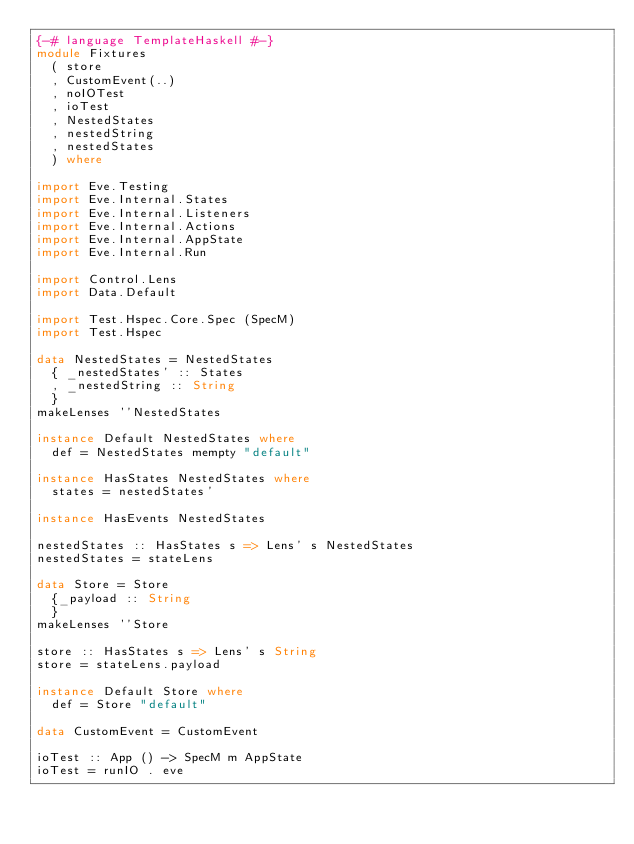<code> <loc_0><loc_0><loc_500><loc_500><_Haskell_>{-# language TemplateHaskell #-}
module Fixtures
  ( store
  , CustomEvent(..)
  , noIOTest
  , ioTest
  , NestedStates
  , nestedString
  , nestedStates
  ) where

import Eve.Testing
import Eve.Internal.States
import Eve.Internal.Listeners
import Eve.Internal.Actions
import Eve.Internal.AppState
import Eve.Internal.Run

import Control.Lens
import Data.Default

import Test.Hspec.Core.Spec (SpecM)
import Test.Hspec

data NestedStates = NestedStates
  { _nestedStates' :: States
  , _nestedString :: String
  }
makeLenses ''NestedStates

instance Default NestedStates where
  def = NestedStates mempty "default"

instance HasStates NestedStates where
  states = nestedStates'

instance HasEvents NestedStates

nestedStates :: HasStates s => Lens' s NestedStates
nestedStates = stateLens

data Store = Store
  {_payload :: String
  }
makeLenses ''Store

store :: HasStates s => Lens' s String
store = stateLens.payload

instance Default Store where
  def = Store "default"

data CustomEvent = CustomEvent

ioTest :: App () -> SpecM m AppState
ioTest = runIO . eve
</code> 